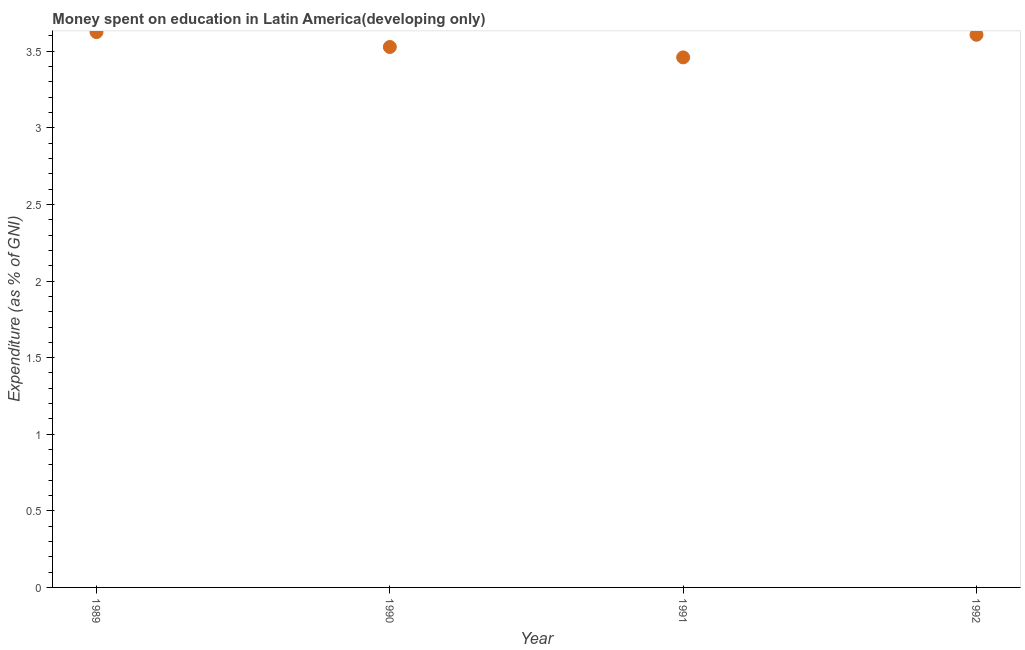What is the expenditure on education in 1990?
Your response must be concise. 3.53. Across all years, what is the maximum expenditure on education?
Provide a short and direct response. 3.63. Across all years, what is the minimum expenditure on education?
Keep it short and to the point. 3.46. In which year was the expenditure on education maximum?
Offer a very short reply. 1989. In which year was the expenditure on education minimum?
Offer a very short reply. 1991. What is the sum of the expenditure on education?
Ensure brevity in your answer.  14.22. What is the difference between the expenditure on education in 1989 and 1991?
Your answer should be compact. 0.17. What is the average expenditure on education per year?
Ensure brevity in your answer.  3.56. What is the median expenditure on education?
Your answer should be very brief. 3.57. What is the ratio of the expenditure on education in 1989 to that in 1991?
Your answer should be very brief. 1.05. What is the difference between the highest and the second highest expenditure on education?
Offer a terse response. 0.02. Is the sum of the expenditure on education in 1989 and 1990 greater than the maximum expenditure on education across all years?
Make the answer very short. Yes. What is the difference between the highest and the lowest expenditure on education?
Offer a terse response. 0.17. Does the expenditure on education monotonically increase over the years?
Offer a very short reply. No. How many years are there in the graph?
Give a very brief answer. 4. What is the difference between two consecutive major ticks on the Y-axis?
Provide a short and direct response. 0.5. Does the graph contain any zero values?
Provide a succinct answer. No. Does the graph contain grids?
Make the answer very short. No. What is the title of the graph?
Offer a terse response. Money spent on education in Latin America(developing only). What is the label or title of the Y-axis?
Give a very brief answer. Expenditure (as % of GNI). What is the Expenditure (as % of GNI) in 1989?
Your response must be concise. 3.63. What is the Expenditure (as % of GNI) in 1990?
Ensure brevity in your answer.  3.53. What is the Expenditure (as % of GNI) in 1991?
Keep it short and to the point. 3.46. What is the Expenditure (as % of GNI) in 1992?
Provide a short and direct response. 3.61. What is the difference between the Expenditure (as % of GNI) in 1989 and 1990?
Give a very brief answer. 0.1. What is the difference between the Expenditure (as % of GNI) in 1989 and 1991?
Ensure brevity in your answer.  0.17. What is the difference between the Expenditure (as % of GNI) in 1989 and 1992?
Your response must be concise. 0.02. What is the difference between the Expenditure (as % of GNI) in 1990 and 1991?
Provide a succinct answer. 0.07. What is the difference between the Expenditure (as % of GNI) in 1990 and 1992?
Provide a succinct answer. -0.08. What is the difference between the Expenditure (as % of GNI) in 1991 and 1992?
Your answer should be very brief. -0.15. What is the ratio of the Expenditure (as % of GNI) in 1989 to that in 1990?
Ensure brevity in your answer.  1.03. What is the ratio of the Expenditure (as % of GNI) in 1989 to that in 1991?
Offer a terse response. 1.05. What is the ratio of the Expenditure (as % of GNI) in 1990 to that in 1991?
Your response must be concise. 1.02. What is the ratio of the Expenditure (as % of GNI) in 1990 to that in 1992?
Your answer should be compact. 0.98. 